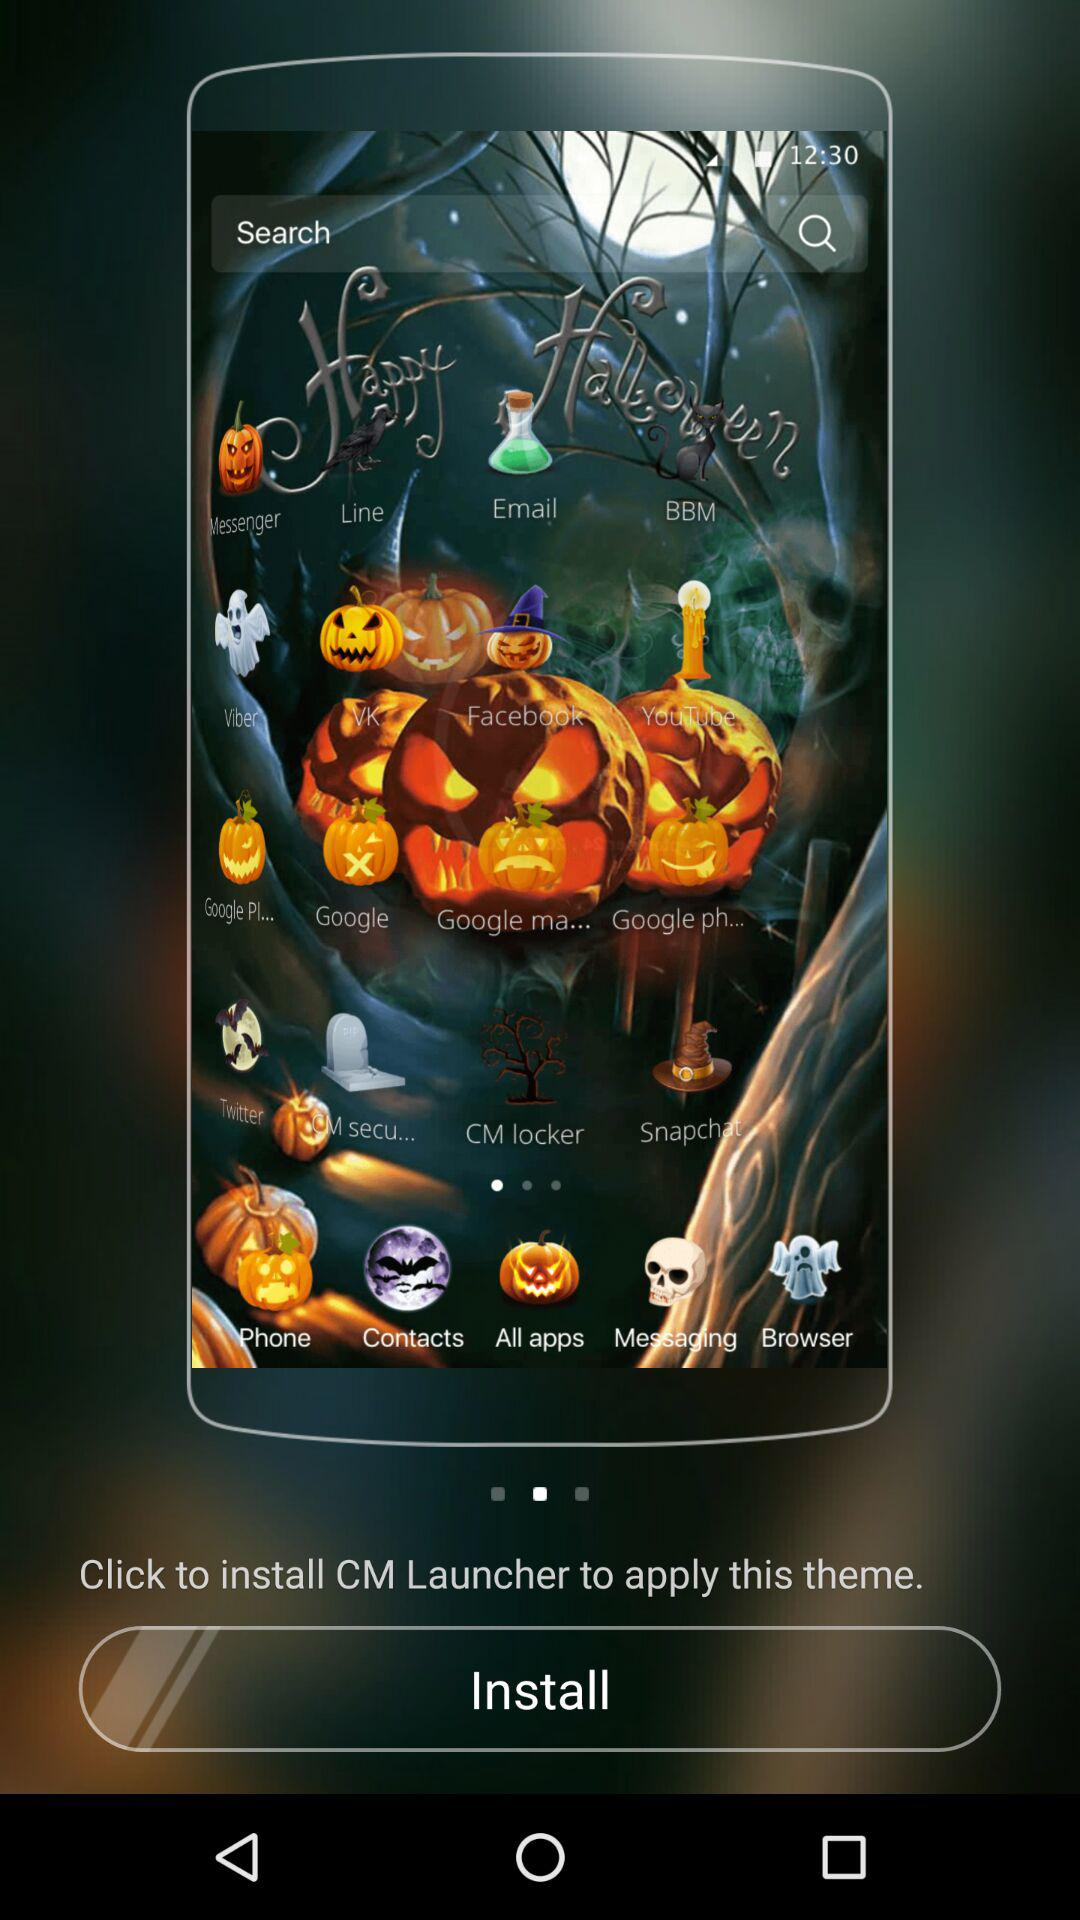Which launcher is being asked to be installed? The launcher that is being asked to be installed is "CM Launcher". 